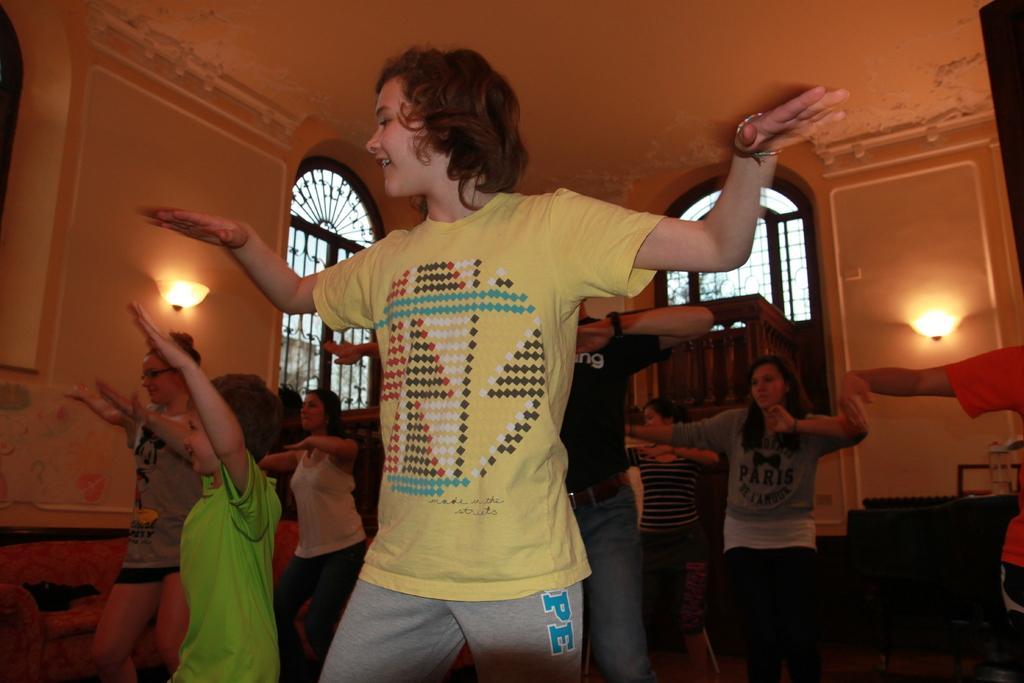Describe this image in one or two sentences. This picture is taken in a room. There is a girl in the center wearing a yellow t shirt and grey trousers and she is dancing. Beside her there is a kid wearing a green t shirt. In the background there are people dancing. In the background there is a wall with windows and lights. 